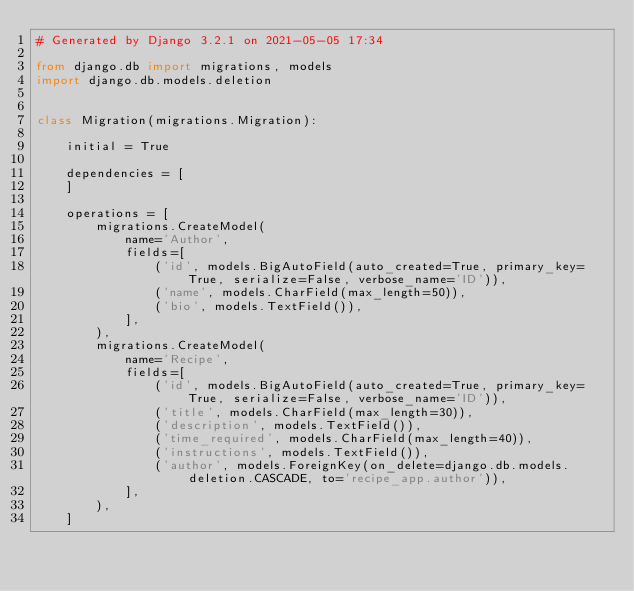Convert code to text. <code><loc_0><loc_0><loc_500><loc_500><_Python_># Generated by Django 3.2.1 on 2021-05-05 17:34

from django.db import migrations, models
import django.db.models.deletion


class Migration(migrations.Migration):

    initial = True

    dependencies = [
    ]

    operations = [
        migrations.CreateModel(
            name='Author',
            fields=[
                ('id', models.BigAutoField(auto_created=True, primary_key=True, serialize=False, verbose_name='ID')),
                ('name', models.CharField(max_length=50)),
                ('bio', models.TextField()),
            ],
        ),
        migrations.CreateModel(
            name='Recipe',
            fields=[
                ('id', models.BigAutoField(auto_created=True, primary_key=True, serialize=False, verbose_name='ID')),
                ('title', models.CharField(max_length=30)),
                ('description', models.TextField()),
                ('time_required', models.CharField(max_length=40)),
                ('instructions', models.TextField()),
                ('author', models.ForeignKey(on_delete=django.db.models.deletion.CASCADE, to='recipe_app.author')),
            ],
        ),
    ]
</code> 